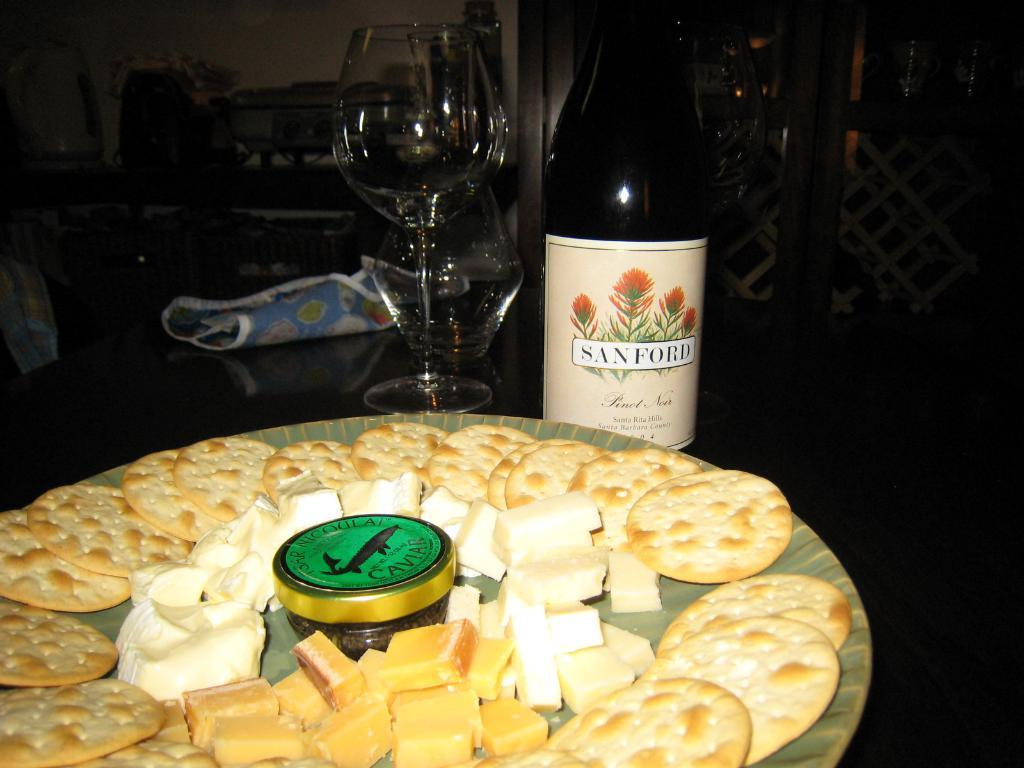<image>
Relay a brief, clear account of the picture shown. A bottle of Sanford wine is behind a platter of cheese and crackers. 